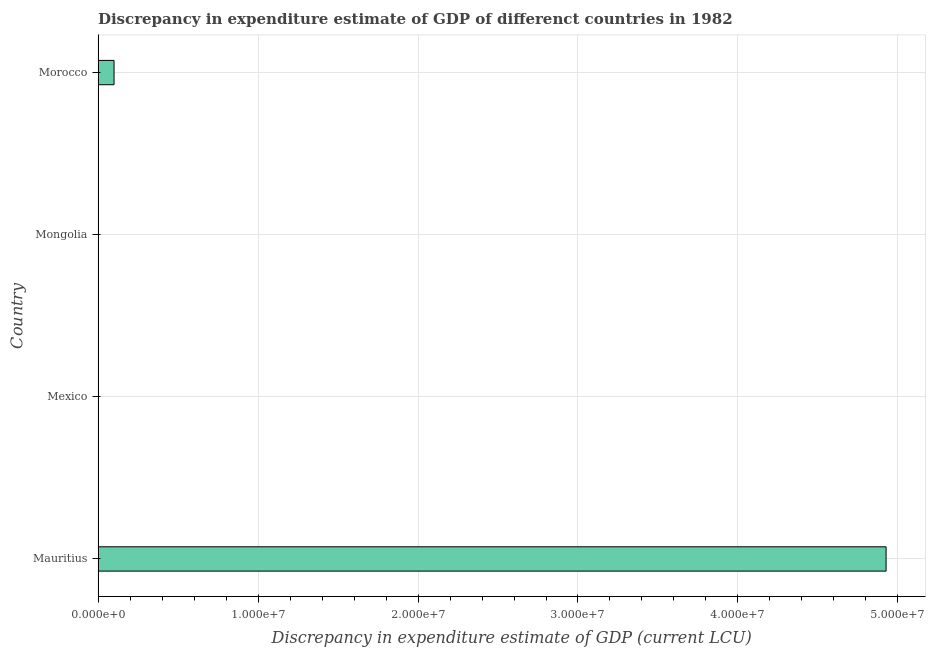What is the title of the graph?
Keep it short and to the point. Discrepancy in expenditure estimate of GDP of differenct countries in 1982. What is the label or title of the X-axis?
Your answer should be very brief. Discrepancy in expenditure estimate of GDP (current LCU). What is the label or title of the Y-axis?
Your response must be concise. Country. Across all countries, what is the maximum discrepancy in expenditure estimate of gdp?
Provide a short and direct response. 4.93e+07. Across all countries, what is the minimum discrepancy in expenditure estimate of gdp?
Give a very brief answer. 0. In which country was the discrepancy in expenditure estimate of gdp maximum?
Your answer should be compact. Mauritius. What is the sum of the discrepancy in expenditure estimate of gdp?
Ensure brevity in your answer.  5.03e+07. What is the difference between the discrepancy in expenditure estimate of gdp in Mauritius and Morocco?
Provide a short and direct response. 4.83e+07. What is the average discrepancy in expenditure estimate of gdp per country?
Ensure brevity in your answer.  1.26e+07. What is the median discrepancy in expenditure estimate of gdp?
Your response must be concise. 5.00e+05. Is the difference between the discrepancy in expenditure estimate of gdp in Mauritius and Morocco greater than the difference between any two countries?
Offer a very short reply. No. Is the sum of the discrepancy in expenditure estimate of gdp in Mauritius and Morocco greater than the maximum discrepancy in expenditure estimate of gdp across all countries?
Make the answer very short. Yes. What is the difference between the highest and the lowest discrepancy in expenditure estimate of gdp?
Provide a succinct answer. 4.93e+07. How many countries are there in the graph?
Your answer should be very brief. 4. Are the values on the major ticks of X-axis written in scientific E-notation?
Provide a short and direct response. Yes. What is the Discrepancy in expenditure estimate of GDP (current LCU) in Mauritius?
Offer a very short reply. 4.93e+07. What is the Discrepancy in expenditure estimate of GDP (current LCU) in Mexico?
Ensure brevity in your answer.  0. What is the Discrepancy in expenditure estimate of GDP (current LCU) in Mongolia?
Offer a very short reply. 0. What is the Discrepancy in expenditure estimate of GDP (current LCU) in Morocco?
Make the answer very short. 1.00e+06. What is the difference between the Discrepancy in expenditure estimate of GDP (current LCU) in Mauritius and Morocco?
Offer a very short reply. 4.83e+07. What is the ratio of the Discrepancy in expenditure estimate of GDP (current LCU) in Mauritius to that in Morocco?
Provide a short and direct response. 49.26. 